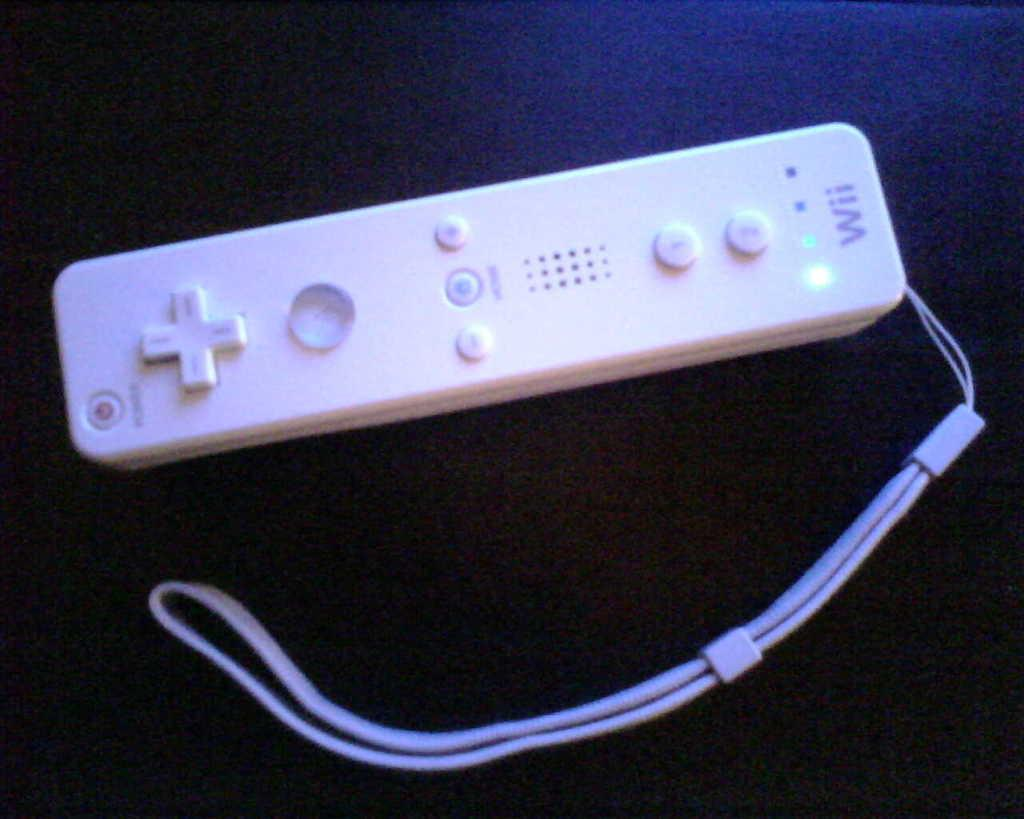<image>
Share a concise interpretation of the image provided. A white Wii remote control with a strap is on a black background. 